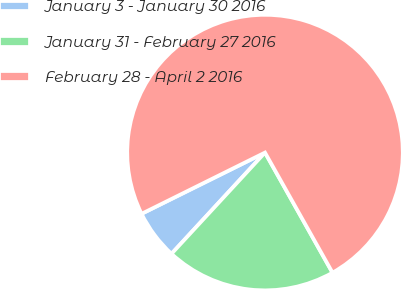Convert chart. <chart><loc_0><loc_0><loc_500><loc_500><pie_chart><fcel>January 3 - January 30 2016<fcel>January 31 - February 27 2016<fcel>February 28 - April 2 2016<nl><fcel>5.8%<fcel>20.02%<fcel>74.18%<nl></chart> 